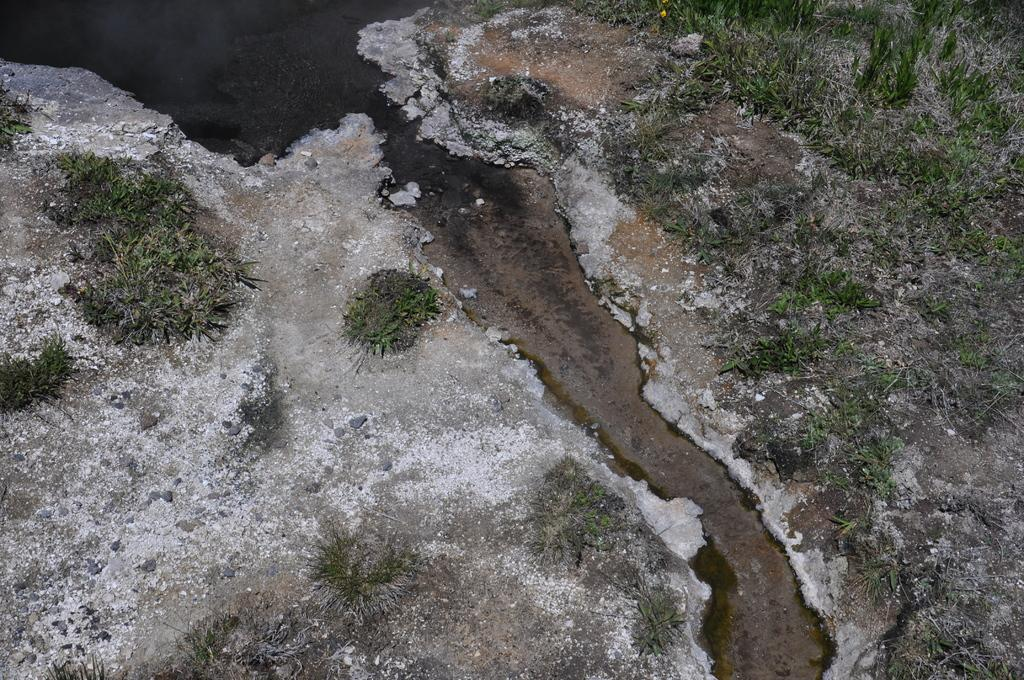What type of vegetation is present in the image? There are shrubs in the image. What other objects can be seen in the image? There are stones and a water path in the image. What type of pet is visible in the image? There is no pet present in the image. Where is the meeting taking place in the image? There is no meeting depicted in the image. 